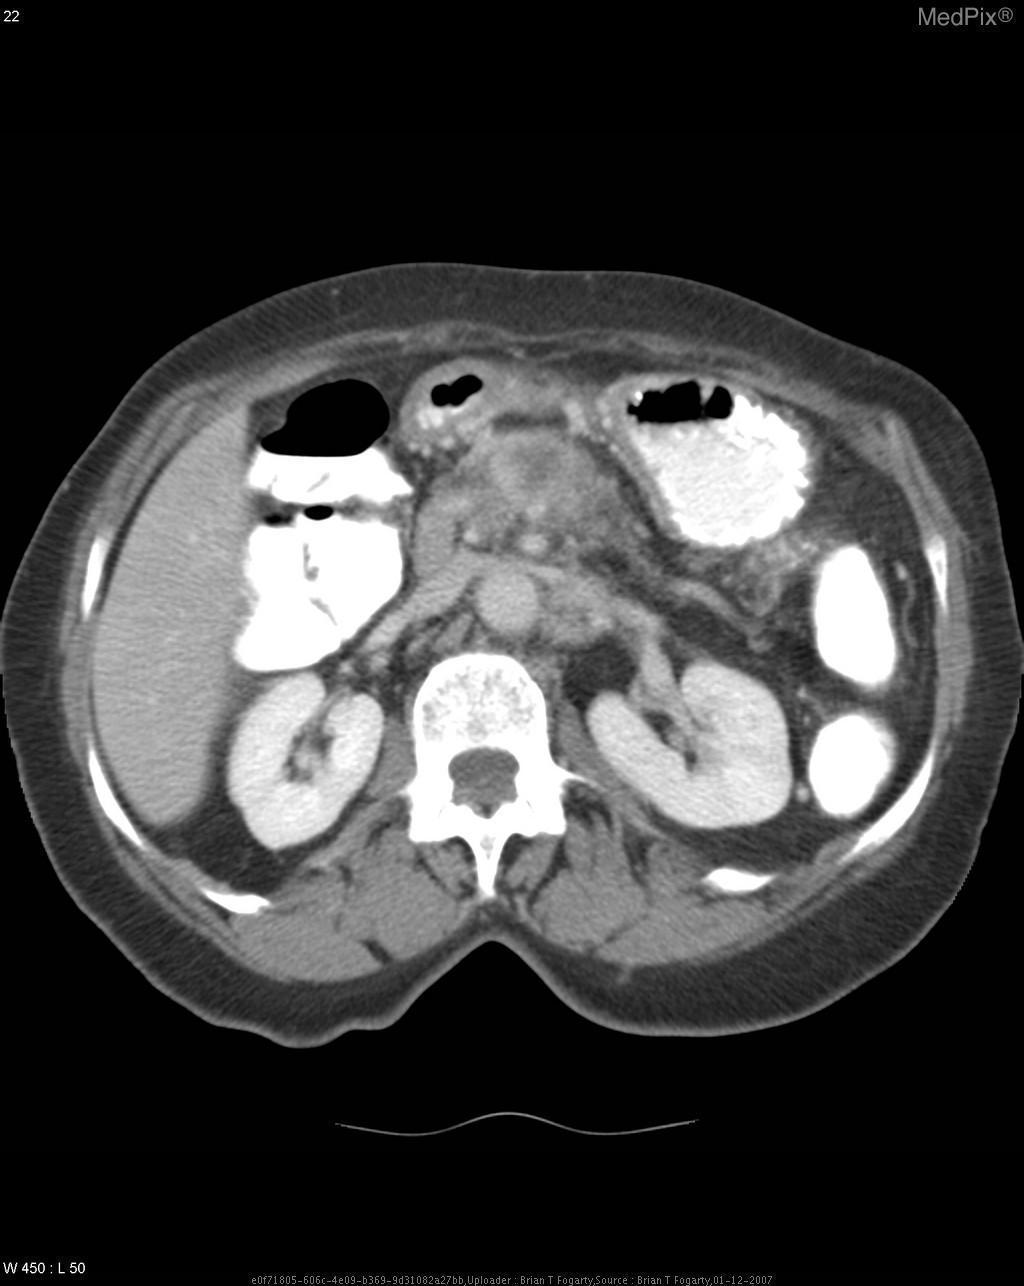What are the opacities to the left?
Be succinct. Contrast in the intestines. Is there leakage of contrast?
Short answer required. No. Is there ascites?
Answer briefly. No. 